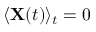Convert formula to latex. <formula><loc_0><loc_0><loc_500><loc_500>\langle X ( t ) \rangle _ { t } = 0</formula> 